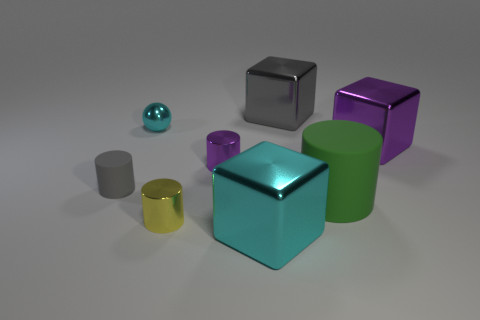There is a yellow cylinder that is the same material as the cyan sphere; what is its size?
Provide a succinct answer. Small. Is the number of shiny things greater than the number of gray rubber cylinders?
Make the answer very short. Yes. What material is the green object that is the same size as the purple metal cube?
Make the answer very short. Rubber. Is the size of the green thing that is right of the gray cube the same as the gray cylinder?
Keep it short and to the point. No. How many cylinders are either large green matte things or small purple objects?
Provide a short and direct response. 2. There is a gray object in front of the gray metal block; what material is it?
Provide a succinct answer. Rubber. Are there fewer big purple metallic things than tiny yellow rubber objects?
Provide a succinct answer. No. There is a shiny cube that is both behind the purple cylinder and on the left side of the big matte object; how big is it?
Provide a succinct answer. Large. What is the size of the metal cube that is right of the big rubber cylinder behind the shiny block that is in front of the purple metal cylinder?
Your answer should be compact. Large. How many other things are the same color as the small matte cylinder?
Provide a succinct answer. 1. 